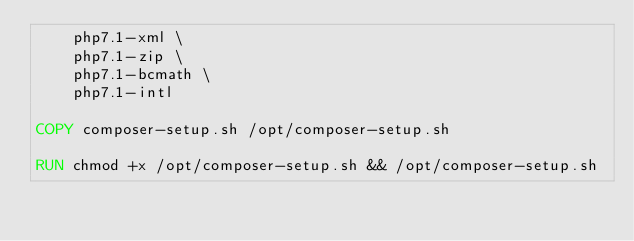Convert code to text. <code><loc_0><loc_0><loc_500><loc_500><_Dockerfile_>    php7.1-xml \
    php7.1-zip \
    php7.1-bcmath \
    php7.1-intl

COPY composer-setup.sh /opt/composer-setup.sh

RUN chmod +x /opt/composer-setup.sh && /opt/composer-setup.sh

</code> 